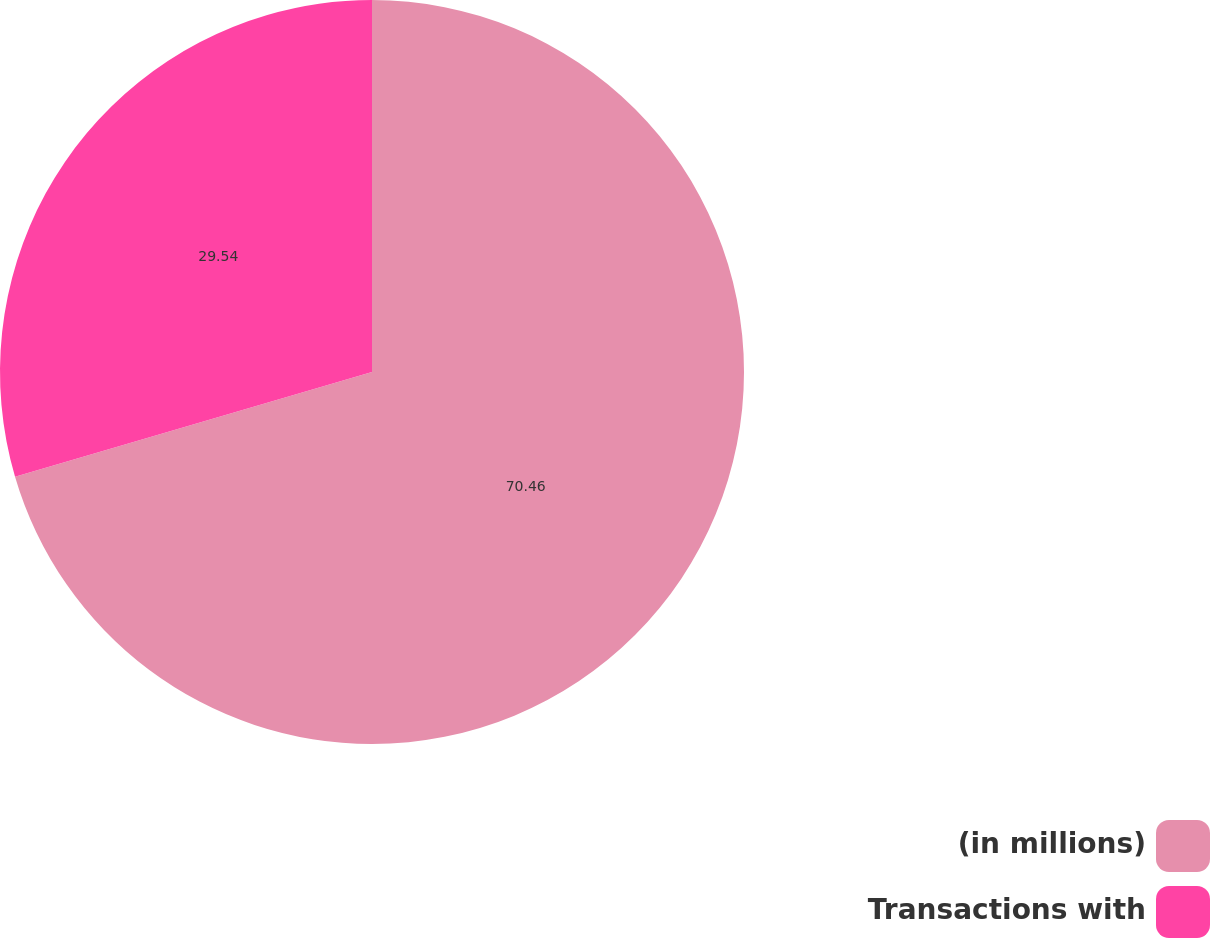Convert chart to OTSL. <chart><loc_0><loc_0><loc_500><loc_500><pie_chart><fcel>(in millions)<fcel>Transactions with<nl><fcel>70.46%<fcel>29.54%<nl></chart> 